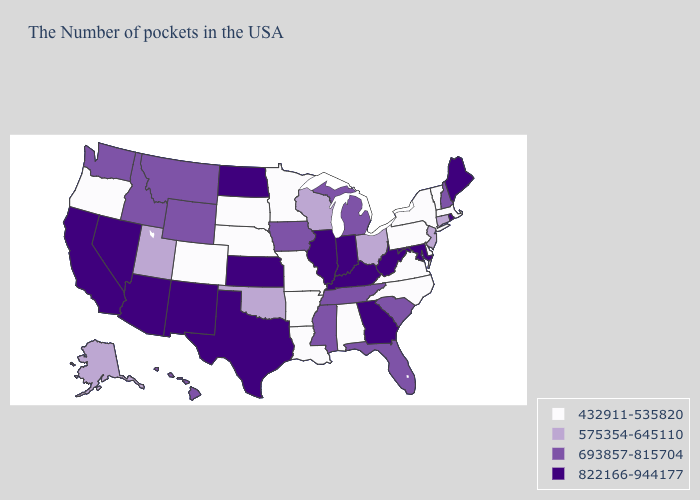What is the value of Iowa?
Quick response, please. 693857-815704. What is the highest value in the USA?
Be succinct. 822166-944177. How many symbols are there in the legend?
Short answer required. 4. Does North Carolina have the lowest value in the South?
Write a very short answer. Yes. Among the states that border Florida , which have the highest value?
Short answer required. Georgia. Does Rhode Island have a higher value than Maryland?
Quick response, please. No. What is the lowest value in the USA?
Answer briefly. 432911-535820. What is the highest value in the USA?
Write a very short answer. 822166-944177. Does the first symbol in the legend represent the smallest category?
Keep it brief. Yes. Does the first symbol in the legend represent the smallest category?
Write a very short answer. Yes. What is the value of Tennessee?
Write a very short answer. 693857-815704. Name the states that have a value in the range 693857-815704?
Short answer required. New Hampshire, South Carolina, Florida, Michigan, Tennessee, Mississippi, Iowa, Wyoming, Montana, Idaho, Washington, Hawaii. Name the states that have a value in the range 575354-645110?
Quick response, please. Connecticut, New Jersey, Ohio, Wisconsin, Oklahoma, Utah, Alaska. Name the states that have a value in the range 822166-944177?
Give a very brief answer. Maine, Rhode Island, Maryland, West Virginia, Georgia, Kentucky, Indiana, Illinois, Kansas, Texas, North Dakota, New Mexico, Arizona, Nevada, California. What is the value of Maine?
Write a very short answer. 822166-944177. 